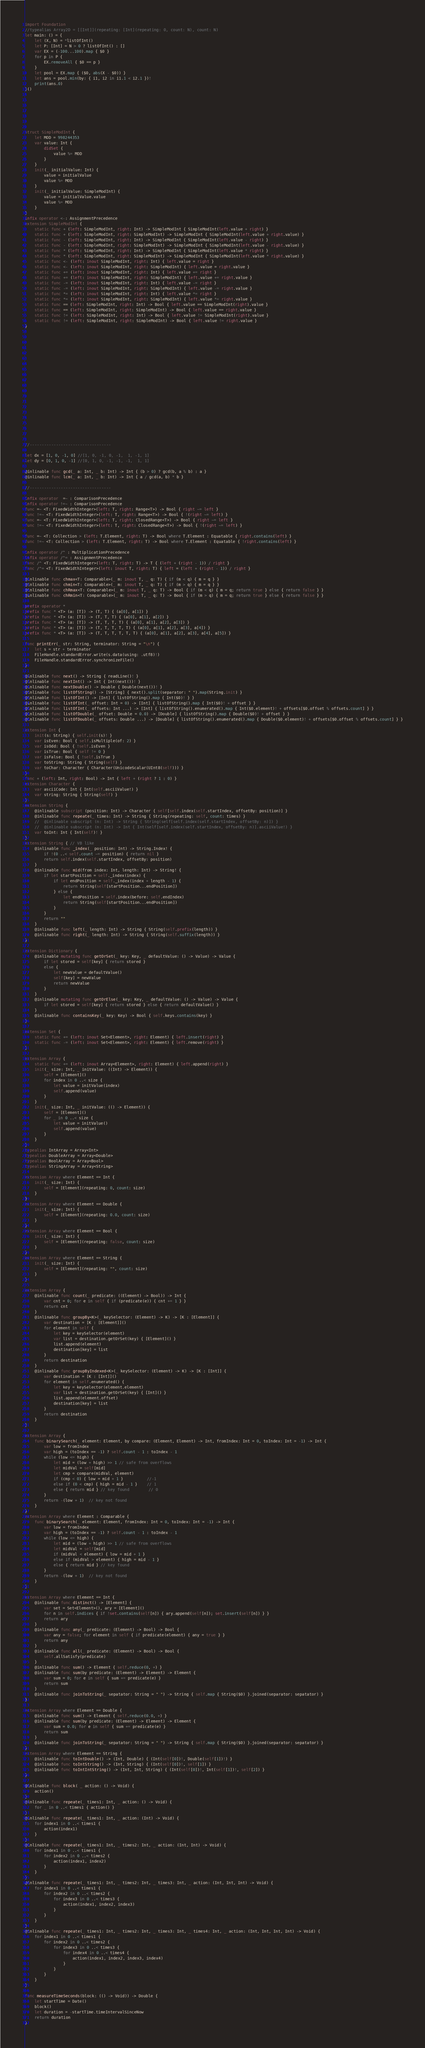<code> <loc_0><loc_0><loc_500><loc_500><_Swift_>







import Foundation
//typealias Array2D = [[Int]](repeating: [Int](repeating: 0, count: N), count: N)
let main: () = {
    let (X, N) = *listOfInt()
    let P: [Int] = N > 0 ? listOfInt() : []
    var EX = (-100...100).map { $0 }
    for p in P {
        EX.removeAll { $0 == p }
    }
    let pool = EX.map { ($0, abs(X - $0)) }
    let ans = pool.min(by: { i1, i2 in i1.1 < i2.1 })!
    print(ans.0)
}()







struct SimpleModInt {
    let MOD = 998244353
    var value: Int {
        didSet {
            value %= MOD
        }
    }
    init(_ initialValue: Int) {
        value = initialValue
        value %= MOD
    }
    init(_ initialValue: SimpleModInt) {
        value = initialValue.value
        value %= MOD
    }
}
infix operator <-: AssignmentPrecedence
extension SimpleModInt {
    static func + (left: SimpleModInt, right: Int) -> SimpleModInt { SimpleModInt(left.value + right) }
    static func + (left: SimpleModInt, right: SimpleModInt) -> SimpleModInt { SimpleModInt(left.value + right.value) }
    static func - (left: SimpleModInt, right: Int) -> SimpleModInt { SimpleModInt(left.value - right) }
    static func - (left: SimpleModInt, right: SimpleModInt) -> SimpleModInt { SimpleModInt(left.value - right.value) }
    static func * (left: SimpleModInt, right: Int) -> SimpleModInt { SimpleModInt(left.value * right) }
    static func * (left: SimpleModInt, right: SimpleModInt) -> SimpleModInt { SimpleModInt(left.value * right.value) }
    static func <- (left: inout SimpleModInt, right: Int) { left.value = right }
    static func <- (left: inout SimpleModInt, right: SimpleModInt) { left.value = right.value }
    static func += (left: inout SimpleModInt, right: Int) { left.value += right }
    static func += (left: inout SimpleModInt, right: SimpleModInt) { left.value += right.value }
    static func -= (left: inout SimpleModInt, right: Int) { left.value -= right }
    static func -= (left: inout SimpleModInt, right: SimpleModInt) { left.value -= right.value }
    static func *= (left: inout SimpleModInt, right: Int) { left.value *= right }
    static func *= (left: inout SimpleModInt, right: SimpleModInt) { left.value *= right.value }
    static func == (left: SimpleModInt, right: Int) -> Bool { left.value == SimpleModInt(right).value }
    static func == (left: SimpleModInt, right: SimpleModInt) -> Bool { left.value == right.value }
    static func != (left: SimpleModInt, right: Int) -> Bool { left.value != SimpleModInt(right).value }
    static func != (left: SimpleModInt, right: SimpleModInt) -> Bool { left.value != right.value }
}





















//----------------------------------

let dx = [1, 0, -1, 0] //[1, 0, -1, 0, -1,  1, -1, 1]
let dy = [0, 1, 0, -1] //[0, 1, 0, -1, -1, -1,  1, 1]

@inlinable func gcd(_ a: Int, _ b: Int) -> Int { (b > 0) ? gcd(b, a % b) : a }
@inlinable func lcm(_ a: Int, _ b: Int) -> Int { a / gcd(a, b) * b }

//----------------------------------

infix operator  =~ : ComparisonPrecedence
infix operator !=~ : ComparisonPrecedence
func =~ <T: FixedWidthInteger>(left: T, right: Range<T>) -> Bool { right ~= left }
func !=~ <T: FixedWidthInteger>(left: T, right: Range<T>) -> Bool { !(right ~= left) }
func =~ <T: FixedWidthInteger>(left: T, right: ClosedRange<T>) -> Bool { right ~= left }
func !=~ <T: FixedWidthInteger>(left: T, right: ClosedRange<T>) -> Bool { !(right ~= left) }

func =~ <T: Collection > (left: T.Element, right: T) -> Bool where T.Element : Equatable { right.contains(left) }
func !=~ <T: Collection > (left: T.Element, right: T) -> Bool where T.Element : Equatable { !right.contains(left) }

infix operator /^ : MultiplicationPrecedence
infix operator /^= : AssignmentPrecedence
func /^ <T: FixedWidthInteger>(left: T, right: T) -> T { (left + (right - 1)) / right }
func /^= <T: FixedWidthInteger>(left: inout T, right: T) { left = (left + (right - 1)) / right }

@inlinable func chmax<T: Comparable>(_ m: inout T, _ q: T) { if (m < q) { m = q } }
@inlinable func chmin<T: Comparable>(_ m: inout T, _ q: T) { if (m > q) { m = q } }
@inlinable func chRmax<T: Comparable>(_ m: inout T, _ q: T) -> Bool { if (m < q) { m = q; return true } else { return false } }
@inlinable func chRmin<T: Comparable>(_ m: inout T, _ q: T) -> Bool { if (m > q) { m = q; return true } else { return false } }

prefix operator *
prefix func * <T> (a: [T]) -> (T, T) { (a[0], a[1]) }
prefix func * <T> (a: [T]) -> (T, T, T) { (a[0], a[1], a[2]) }
prefix func * <T> (a: [T]) -> (T, T, T, T) { (a[0], a[1], a[2], a[3]) }
prefix func * <T> (a: [T]) -> (T, T, T, T, T) { (a[0], a[1], a[2], a[3], a[4]) }
prefix func * <T> (a: [T]) -> (T, T, T, T, T, T) { (a[0], a[1], a[2], a[3], a[4], a[5]) }

func printErr(_ str: String, terminator: String = "\n") {
    let s = str + terminator
    FileHandle.standardError.write(s.data(using: .utf8)!)
    FileHandle.standardError.synchronizeFile()
}

@inlinable func next() -> String { readLine()! }
@inlinable func nextInt() -> Int { Int(next())! }
@inlinable func nextDouble() -> Double { Double(next())! }
@inlinable func listOfString() -> [String] { next().split(separator: " ").map(String.init) }
@inlinable func listOfInt() -> [Int] { listOfString().map { Int($0)! } }
@inlinable func listOfInt(_ offset: Int = 0) -> [Int] { listOfString().map { Int($0)! + offset } }
@inlinable func listOfInt(_ offsets: Int ...) -> [Int] { listOfString().enumerated().map { Int($0.element)! + offsets[$0.offset % offsets.count] } }
@inlinable func listOfDouble(_ offset: Double = 0.0) -> [Double] { listOfString().map { Double($0)! + offset } }
@inlinable func listOfDouble(_ offsets: Double ...) -> [Double] { listOfString().enumerated().map { Double($0.element)! + offsets[$0.offset % offsets.count] } }

extension Int {
    init(s: String) { self.init(s)! }
    var isEven: Bool { self.isMultiple(of: 2) }
    var isOdd: Bool { !self.isEven }
    var isTrue: Bool { self != 0 }
    var isFalse: Bool { !self.isTrue }
    var toString: String { String(self) }
    var toChar: Character { Character(UnicodeScalar(UInt8(self))) }
}
func + (left: Int, right: Bool) -> Int { left + (right ? 1 : 0) }
extension Character {
    var asciiCode: Int { Int(self.asciiValue!) }
    var string: String { String(self) }
}
extension String {
    @inlinable subscript (position: Int) -> Character { self[self.index(self.startIndex, offsetBy: position)] }
    @inlinable func repeate(_ times: Int) -> String { String(repeating: self, count: times) }
    //  @inlinable subscript (n: Int) -> String { String(self[self.index(self.startIndex, offsetBy: n)]) }
    //  @inlinable subscript (n: Int) -> Int { Int(self[self.index(self.startIndex, offsetBy: n)].asciiValue!) }
    var toInt: Int { Int(self)! }
}
extension String { // VB like
    @inlinable func _index(_ position: Int) -> String.Index! {
        if !(0 ..< self.count ~= position) { return nil }
        return self.index(self.startIndex, offsetBy: position)
    }
    @inlinable func mid(from index: Int, length: Int) -> String! {
        if let startPosition = self._index(index) {
            if let endPosition = self._index(index + length - 1) {
                return String(self[startPosition...endPosition])
            } else {
                let endPosition = self.index(before: self.endIndex)
                return String(self[startPosition...endPosition])
            }
        }
        return ""
    }
    @inlinable func left(_ length: Int) -> String { String(self.prefix(length)) }
    @inlinable func right(_ length: Int) -> String { String(self.suffix(length)) }
}

extension Dictionary {
    @inlinable mutating func getOrSet(_ key: Key, _ defaultValue: () -> Value) -> Value {
        if let stored = self[key] { return stored }
        else {
            let newValue = defaultValue()
            self[key] = newValue
            return newValue
        }
    }
    @inlinable mutating func getOrElse(_ key: Key, _ defaultValue: () -> Value) -> Value {
        if let stored = self[key] { return stored } else { return defaultValue() }
    }
    @inlinable func containsKey(_ key: Key) -> Bool { self.keys.contains(key) }
}

extension Set {
    static func += (left: inout Set<Element>, right: Element) { left.insert(right) }
    static func -= (left: inout Set<Element>, right: Element) { left.remove(right) }
}

extension Array {
    static func += (left: inout Array<Element>, right: Element) { left.append(right) }
    init(_ size: Int, _ initValue: ((Int) -> Element)) {
        self = [Element]()
        for index in 0 ..< size {
            let value = initValue(index)
            self.append(value)
        }
    }
    init(_ size: Int, _ initValue: (() -> Element)) {
        self = [Element]()
        for _ in 0 ..< size {
            let value = initValue()
            self.append(value)
        }
    }
}
typealias IntArray = Array<Int>
typealias DoubleArray = Array<Double>
typealias BoolArray = Array<Bool>
typealias StringArray = Array<String>

extension Array where Element == Int {
    init(_ size: Int) {
        self = [Element](repeating: 0, count: size)
    }
}
extension Array where Element == Double {
    init(_ size: Int) {
        self = [Element](repeating: 0.0, count: size)
    }
}
extension Array where Element == Bool {
    init(_ size: Int) {
        self = [Element](repeating: false, count: size)
    }
}
extension Array where Element == String {
    init(_ size: Int) {
        self = [Element](repeating: "", count: size)
    }
}

extension Array {
    @inlinable func count(_ predicate: ((Element) -> Bool)) -> Int {
        var cnt = 0; for e in self { if (predicate(e)) { cnt += 1 } }
        return cnt
    }
    @inlinable func groupBy<K>(_ keySelector: (Element) -> K) -> [K : [Element]] {
        var destination = [K : [Element]]()
        for element in self {
            let key = keySelector(element)
            var list = destination.getOrSet(key) { [Element]() }
            list.append(element)
            destination[key] = list
        }
        return destination
    }
    @inlinable func groupByIndexed<K>(_ keySelector: (Element) -> K) -> [K : [Int]] {
        var destination = [K : [Int]]()
        for element in self.enumerated() {
            let key = keySelector(element.element)
            var list = destination.getOrSet(key) { [Int]() }
            list.append(element.offset)
            destination[key] = list
        }
        return destination
    }
}

extension Array {
    func binarySearch(_ element: Element, by compare: (Element, Element) -> Int, fromIndex: Int = 0, toIndex: Int = -1) -> Int {
        var low = fromIndex
        var high = (toIndex == -1) ? self.count - 1 : toIndex - 1
        while (low <= high) {
            let mid = (low + high) >> 1 // safe from overflows
            let midVal = self[mid]
            let cmp = compare(midVal, element)
            if (cmp < 0) { low = mid + 1 }          //-1
            else if (0 < cmp) { high = mid - 1 }    // 1
            else { return mid } // key found        // 0
        }
        return -(low + 1)  // key not found
    }
}
extension Array where Element : Comparable {
    func binarySearch(_ element: Element, fromIndex: Int = 0, toIndex: Int = -1) -> Int {
        var low = fromIndex
        var high = (toIndex == -1) ? self.count - 1 : toIndex - 1
        while (low <= high) {
            let mid = (low + high) >> 1 // safe from overflows
            let midVal = self[mid]
            if (midVal < element) { low = mid + 1 }
            else if (midVal > element) { high = mid - 1 }
            else { return mid } // key found
        }
        return -(low + 1)  // key not found
    }
}

extension Array where Element == Int {
    @inlinable func distinct() -> [Element] {
        var set = Set<Element>(), ary = [Element]()
        for n in self.indices { if !set.contains(self[n]) { ary.append(self[n]); set.insert(self[n]) } }
        return ary
    }
    @inlinable func any(_ predicate: (Element) -> Bool) -> Bool {
        var any = false; for element in self { if predicate(element) { any = true } }
        return any
    }
    @inlinable func all(_ predicate: (Element) -> Bool) -> Bool {
        self.allSatisfy(predicate)
    }
    @inlinable func sum() -> Element { self.reduce(0, +) }
    @inlinable func sum(by predicate: (Element) -> Element) -> Element {
        var sum = 0; for e in self { sum += predicate(e) }
        return sum
    }
    @inlinable func joinToString(_ sepatator: String = " ") -> String { self.map { String($0) }.joined(separator: sepatator) }
}

extension Array where Element == Double {
    @inlinable func sum() -> Element { self.reduce(0.0, +) }
    @inlinable func sum(by predicate: (Element) -> Element) -> Element {
        var sum = 0.0; for e in self { sum += predicate(e) }
        return sum
    }
    @inlinable func joinToString(_ sepatator: String = " ") -> String { self.map { String($0) }.joined(separator: sepatator) }
}
extension Array where Element == String {
    @inlinable func toIntDouble() -> (Int, Double) { (Int(self[0])!, Double(self[1])!) }
    @inlinable func toIntString() -> (Int, String) { (Int(self[0])!, self[1]) }
    @inlinable func toIntIntString() -> (Int, Int, String) { (Int(self[0])!, Int(self[1])!, self[2]) }
}

@inlinable func block( _ action: () -> Void) {
    action()
}
@inlinable func repeate(_ times1: Int, _ action: () -> Void) {
    for _ in 0 ..< times1 { action() }
}
@inlinable func repeate(_ times1: Int, _ action: (Int) -> Void) {
    for index1 in 0 ..< times1 {
        action(index1)
    }
}
@inlinable func repeate(_ times1: Int, _ times2: Int, _ action: (Int, Int) -> Void) {
    for index1 in 0 ..< times1 {
        for index2 in 0 ..< times2 {
            action(index1, index2)
        }
    }
}
@inlinable func repeate(_ times1: Int, _ times2: Int, _ times3: Int, _ action: (Int, Int, Int) -> Void) {
    for index1 in 0 ..< times1 {
        for index2 in 0 ..< times2 {
            for index3 in 0 ..< times3 {
                action(index1, index2, index3)
            }
        }
    }
}
@inlinable func repeate(_ times1: Int, _ times2: Int, _ times3: Int, _ times4: Int, _ action: (Int, Int, Int, Int) -> Void) {
    for index1 in 0 ..< times1 {
        for index2 in 0 ..< times2 {
            for index3 in 0 ..< times3 {
                for index4 in 0 ..< times4 {
                    action(index1, index2, index3, index4)
                }
            }
        }
    }
}

func measureTimeSeconds(block: (() -> Void)) -> Double {
    let startTime = Date()
    block()
    let duration = -startTime.timeIntervalSinceNow
    return duration
}
</code> 